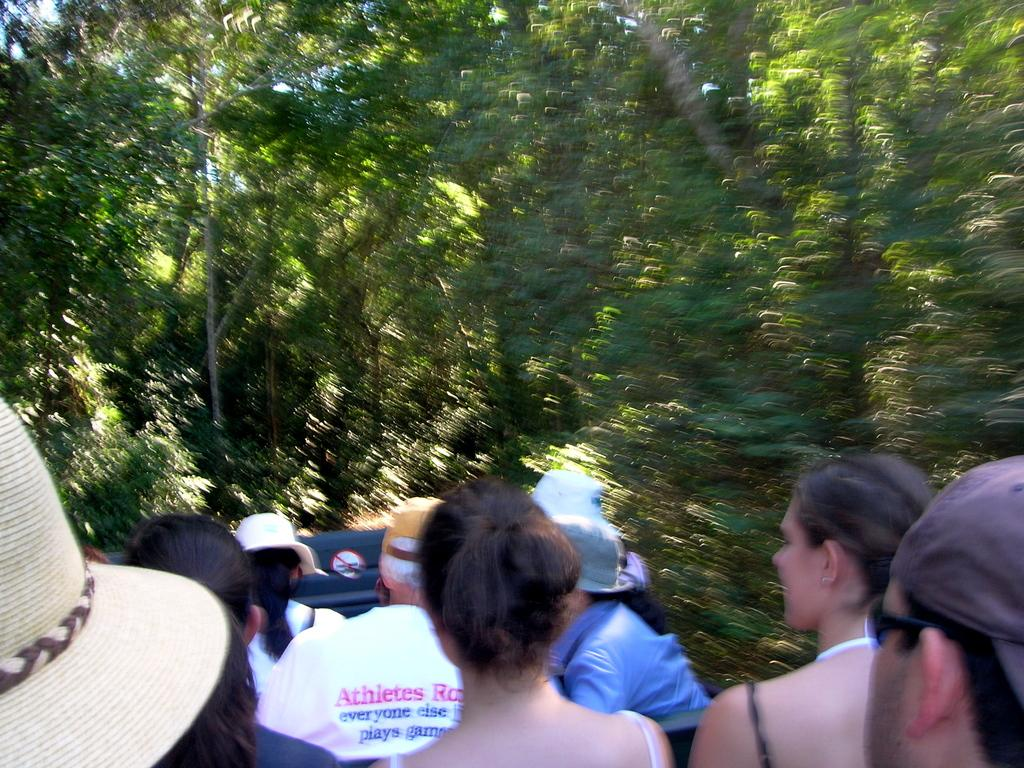Who or what is present at the bottom of the image? There are people at the bottom of the image. What can be seen in the background of the image? There are trees in the background of the image. Where is the drain located in the image? There is no drain present in the image. What type of bear can be seen interacting with the people in the image? There is no bear present in the image. 